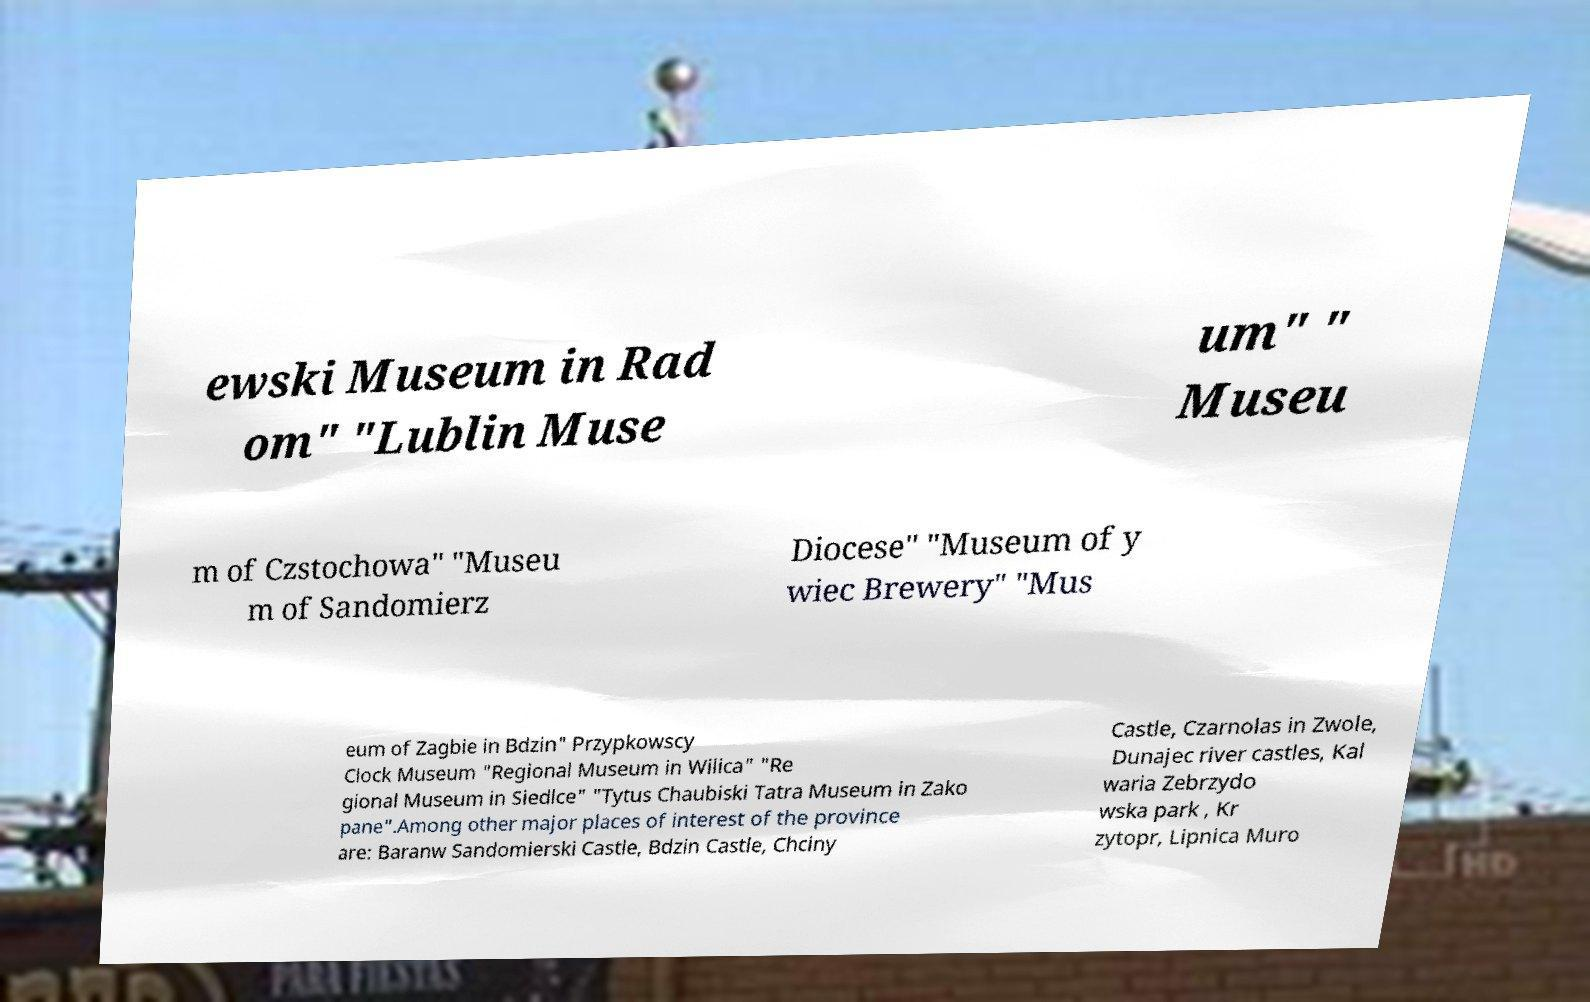Can you accurately transcribe the text from the provided image for me? ewski Museum in Rad om" "Lublin Muse um" " Museu m of Czstochowa" "Museu m of Sandomierz Diocese" "Museum of y wiec Brewery" "Mus eum of Zagbie in Bdzin" Przypkowscy Clock Museum "Regional Museum in Wilica" "Re gional Museum in Siedlce" "Tytus Chaubiski Tatra Museum in Zako pane".Among other major places of interest of the province are: Baranw Sandomierski Castle, Bdzin Castle, Chciny Castle, Czarnolas in Zwole, Dunajec river castles, Kal waria Zebrzydo wska park , Kr zytopr, Lipnica Muro 